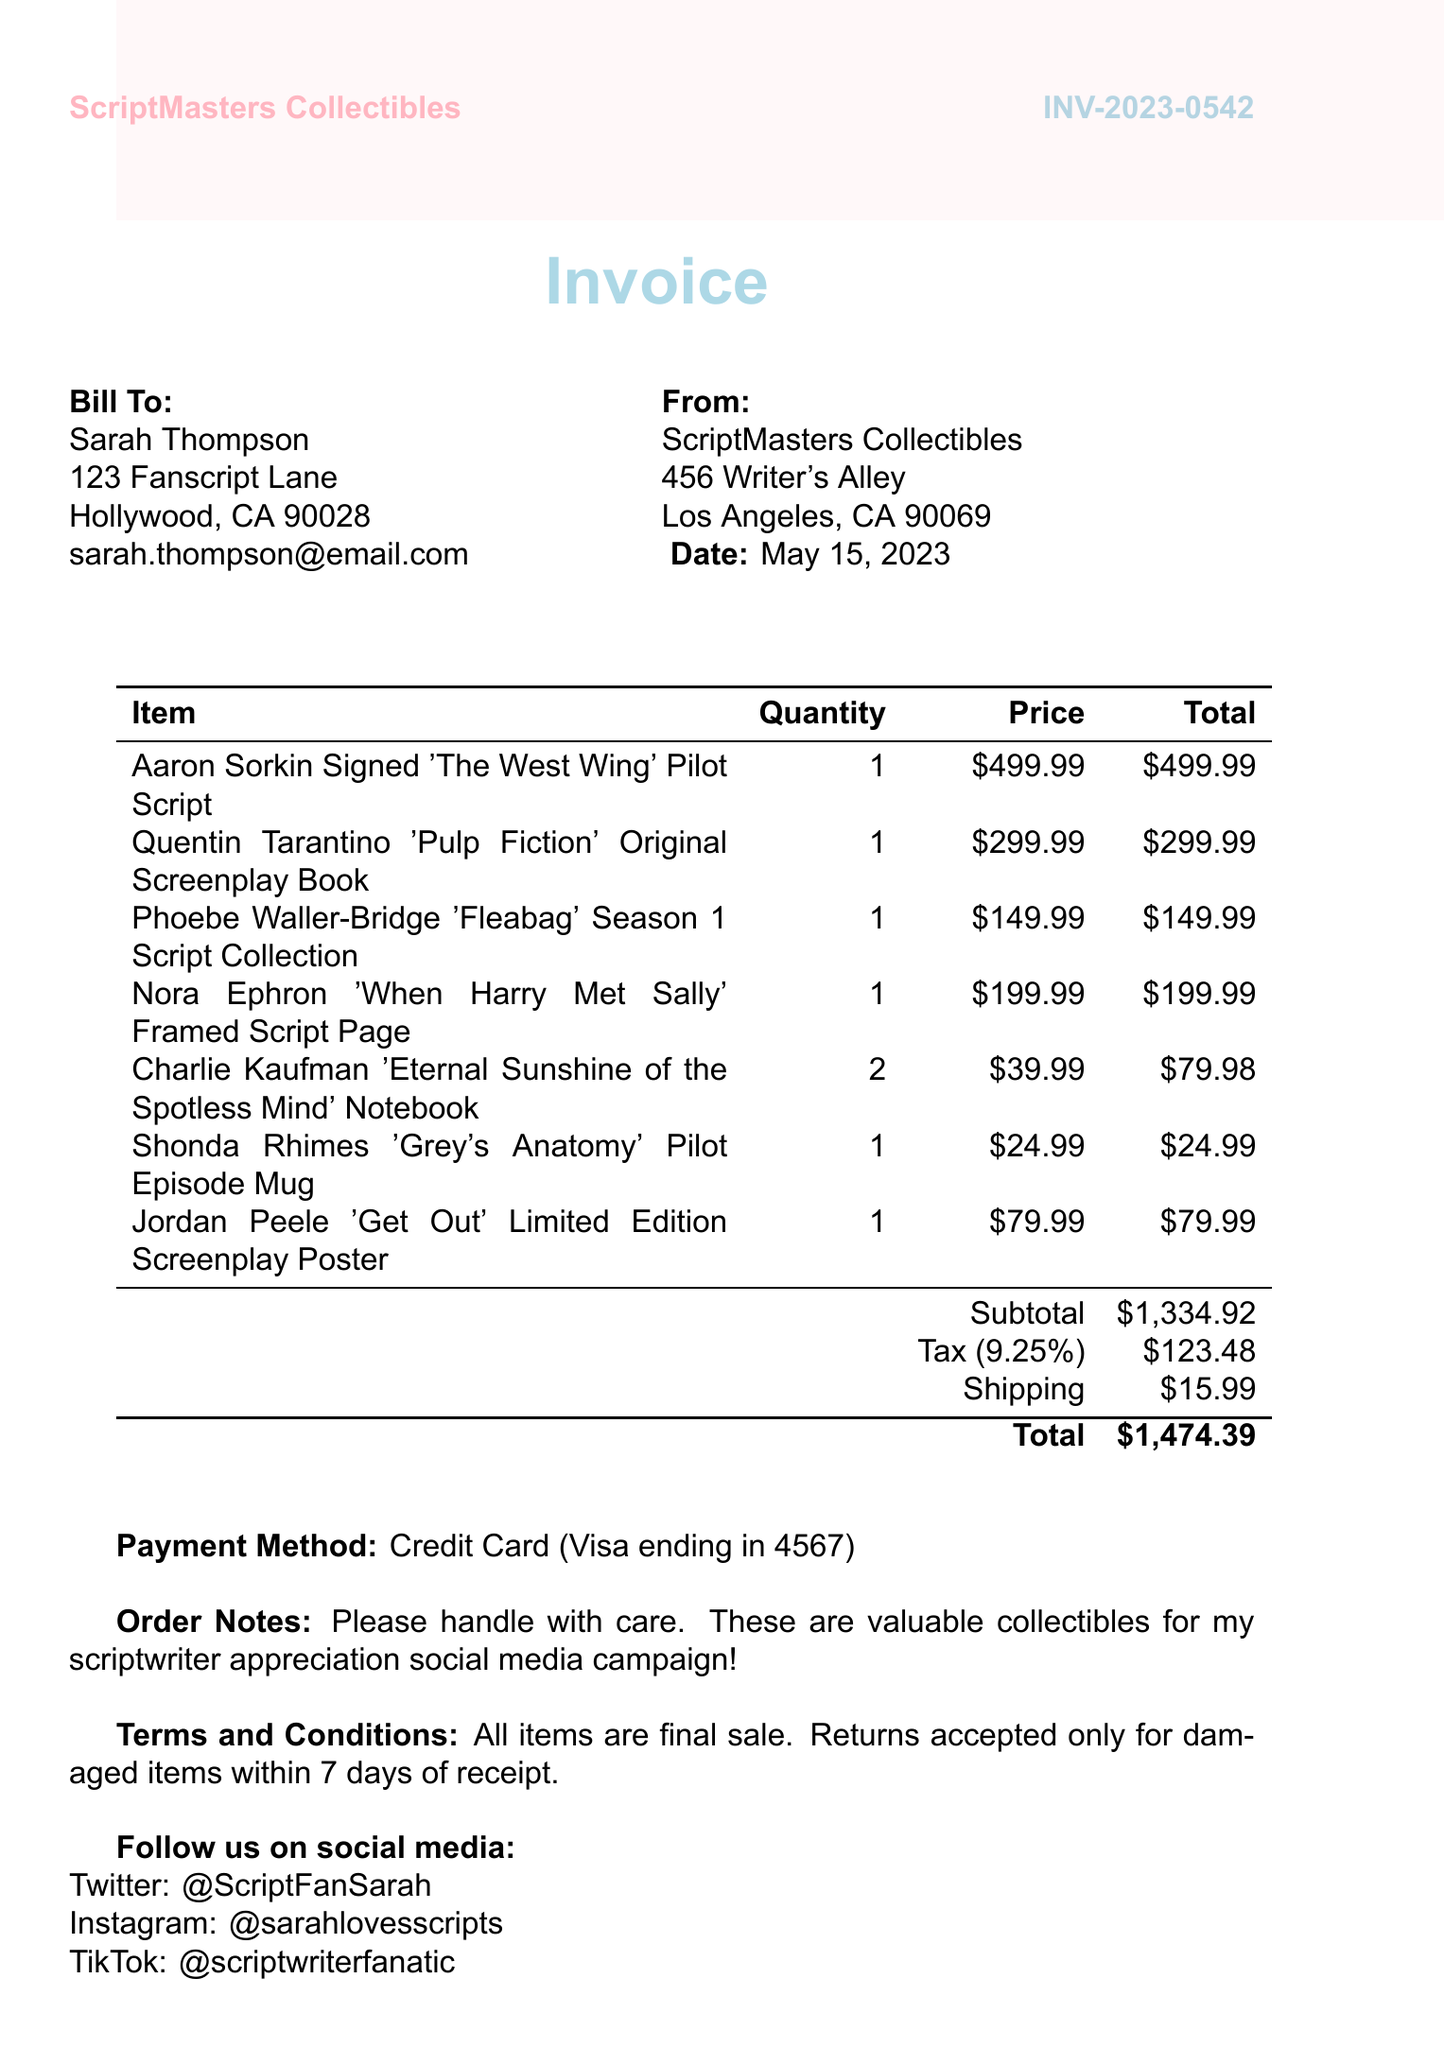What is the invoice number? The invoice number is specified in the header of the document after "INV-".
Answer: INV-2023-0542 Who is the seller? The seller's name and address are provided at the top of the invoice under "From:".
Answer: ScriptMasters Collectibles What is the total amount? The total amount is indicated in the summary section of the invoice.
Answer: $1,474.39 How many items are in the order? The total number of collectible items can be found by counting the individual lines in the itemized list.
Answer: 7 What is the shipping charge? The shipping charge is stated in the summary section of the invoice.
Answer: $15.99 What is the tax rate applied? The tax rate is indicated in the section where tax is calculated.
Answer: 9.25% What method of payment was used? The payment method is specified in the payment section of the invoice.
Answer: Credit Card (Visa ending in 4567) Who is the customer? The customer's name is listed in the "Bill To:" section.
Answer: Sarah Thompson What special instructions did the customer include? The order notes mention specific handling instructions for the items.
Answer: Please handle with care. These are valuable collectibles for my scriptwriter appreciation social media campaign! 